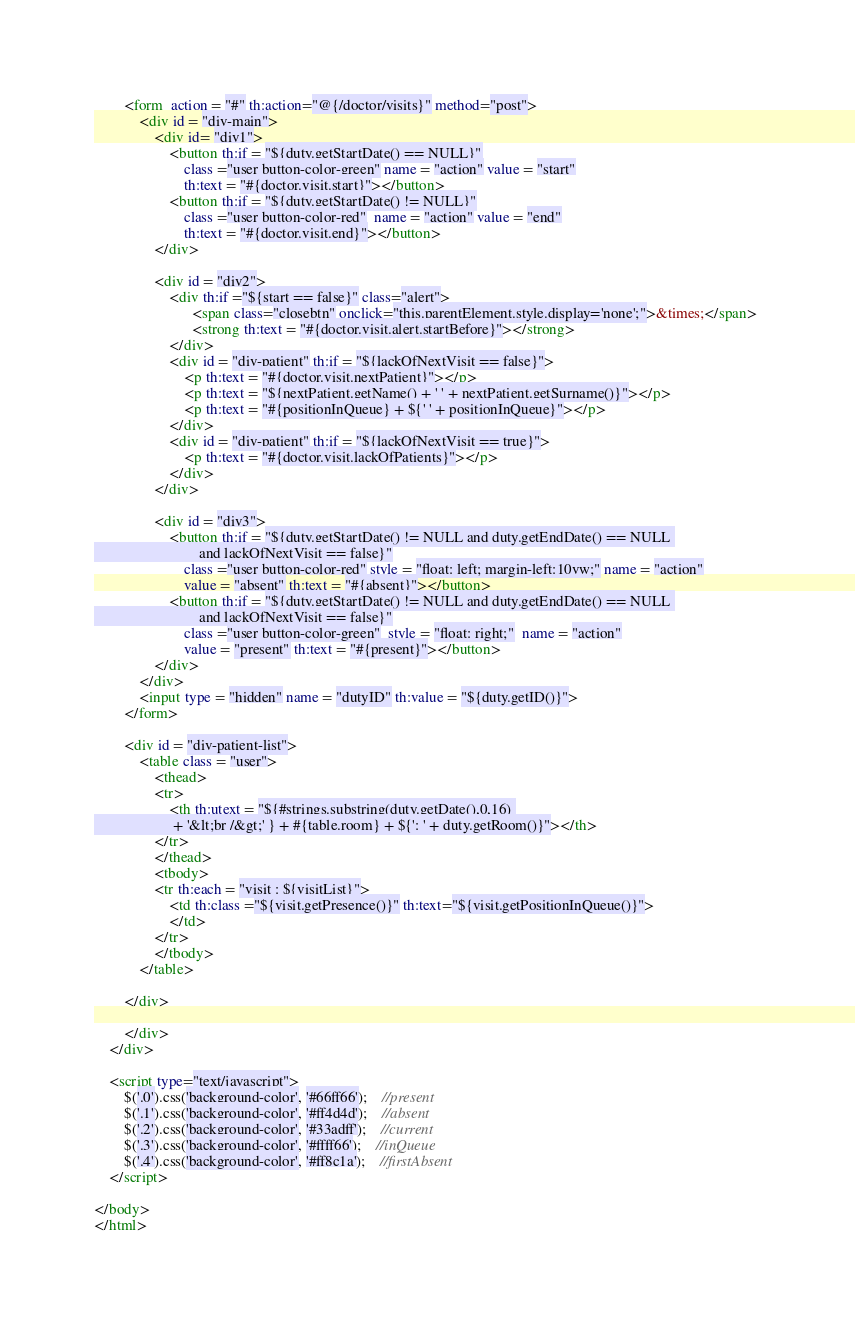Convert code to text. <code><loc_0><loc_0><loc_500><loc_500><_HTML_>		<form  action = "#" th:action="@{/doctor/visits}" method="post">
			<div id = "div-main">
				<div id= "div1">
					<button th:if = "${duty.getStartDate() == NULL}"
						class ="user button-color-green" name = "action" value = "start"
						th:text = "#{doctor.visit.start}"></button>
					<button th:if = "${duty.getStartDate() != NULL}"
						class ="user button-color-red"  name = "action" value = "end"
						th:text = "#{doctor.visit.end}"></button>
				</div>
				
				<div id = "div2">
					<div th:if ="${start == false}" class="alert">
						  <span class="closebtn" onclick="this.parentElement.style.display='none';">&times;</span> 
						  <strong th:text = "#{doctor.visit.alert.startBefore}"></strong>
					</div>
					<div id = "div-patient" th:if = "${lackOfNextVisit == false}">
						<p th:text = "#{doctor.visit.nextPatient}"></p>
						<p th:text = "${nextPatient.getName() + ' ' + nextPatient.getSurname()}"></p>
						<p th:text = "#{positionInQueue} + ${' ' + positionInQueue}"></p>
					</div>
					<div id = "div-patient" th:if = "${lackOfNextVisit == true}">
						<p th:text = "#{doctor.visit.lackOfPatients}"></p>
					</div>
				</div>
				
				<div id = "div3">
					<button th:if = "${duty.getStartDate() != NULL and duty.getEndDate() == NULL 
							and lackOfNextVisit == false}"
						class ="user button-color-red" style = "float: left; margin-left:10vw;" name = "action" 
						value = "absent" th:text = "#{absent}"></button>
					<button th:if = "${duty.getStartDate() != NULL and duty.getEndDate() == NULL 
							and lackOfNextVisit == false}"
						class ="user button-color-green"  style = "float: right;"  name = "action"
					 	value = "present" th:text = "#{present}"></button>	
				</div>
			</div>
			<input type = "hidden" name = "dutyID" th:value = "${duty.getID()}">
		</form>
		
		<div id = "div-patient-list">
			<table class = "user">
				<thead>
				<tr>
					<th th:utext = "${#strings.substring(duty.getDate(),0,16) 
					 + '&lt;br /&gt;' } + #{table.room} + ${': ' + duty.getRoom()}"></th>
				</tr>
				</thead>
				<tbody>
				<tr th:each = "visit : ${visitList}">
					<td th:class ="${visit.getPresence()}" th:text="${visit.getPositionInQueue()}">
					</td>
				</tr>
				</tbody>
			</table>
			
		</div>
		
		</div>
	</div>
	
	<script type="text/javascript">
		$('.0').css('background-color', '#66ff66');	//present
		$('.1').css('background-color', '#ff4d4d');	//absent
		$('.2').css('background-color', '#33adff');	//current
		$('.3').css('background-color', '#ffff66');	//inQueue
		$('.4').css('background-color', '#ff8c1a');	//firstAbsent
	</script>
	
</body>
</html></code> 